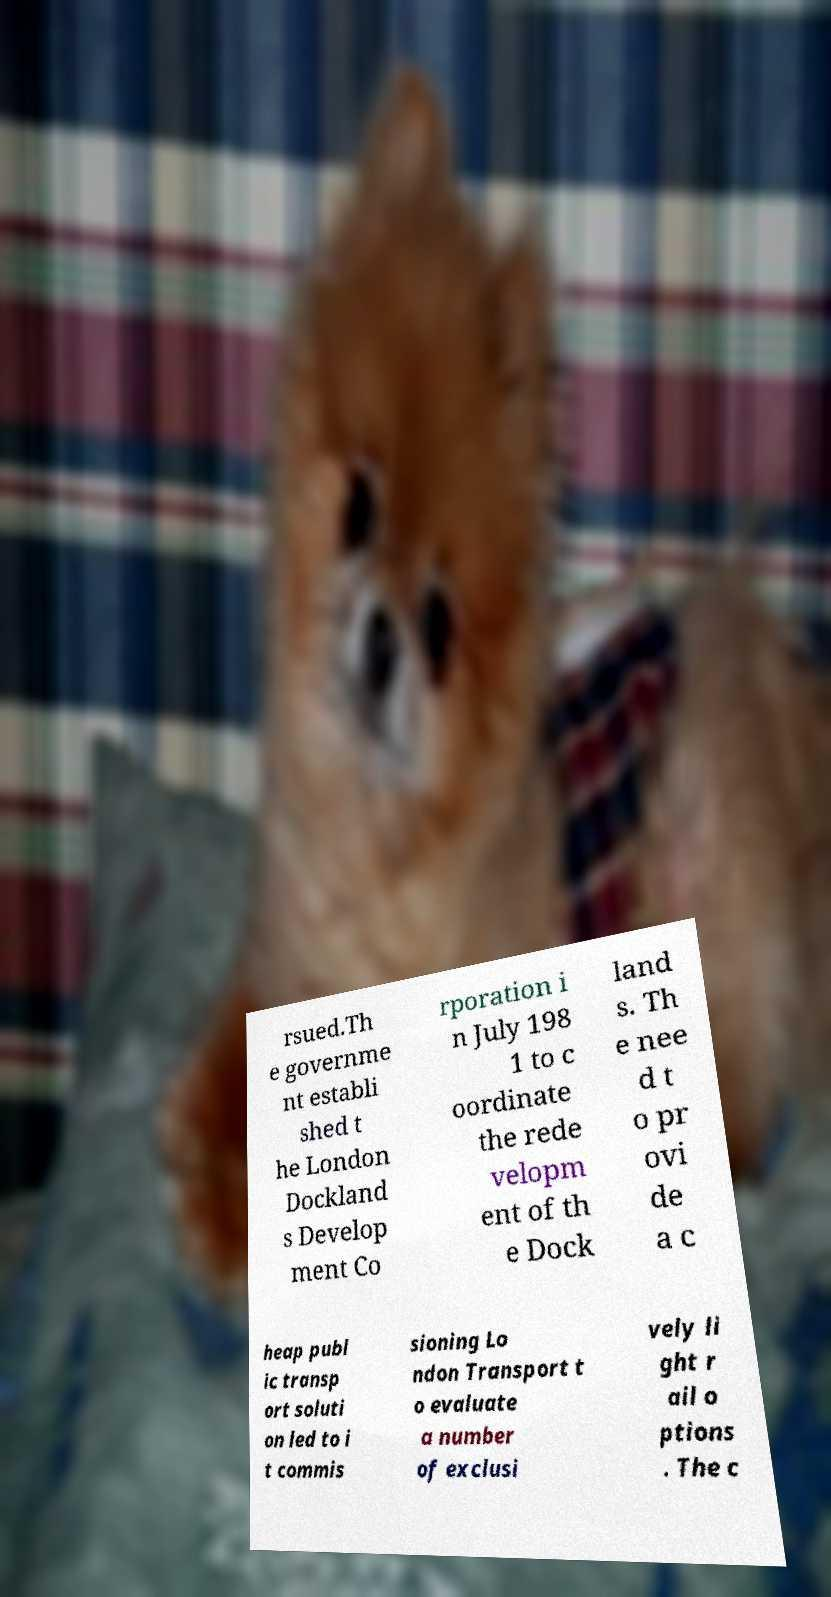For documentation purposes, I need the text within this image transcribed. Could you provide that? rsued.Th e governme nt establi shed t he London Dockland s Develop ment Co rporation i n July 198 1 to c oordinate the rede velopm ent of th e Dock land s. Th e nee d t o pr ovi de a c heap publ ic transp ort soluti on led to i t commis sioning Lo ndon Transport t o evaluate a number of exclusi vely li ght r ail o ptions . The c 